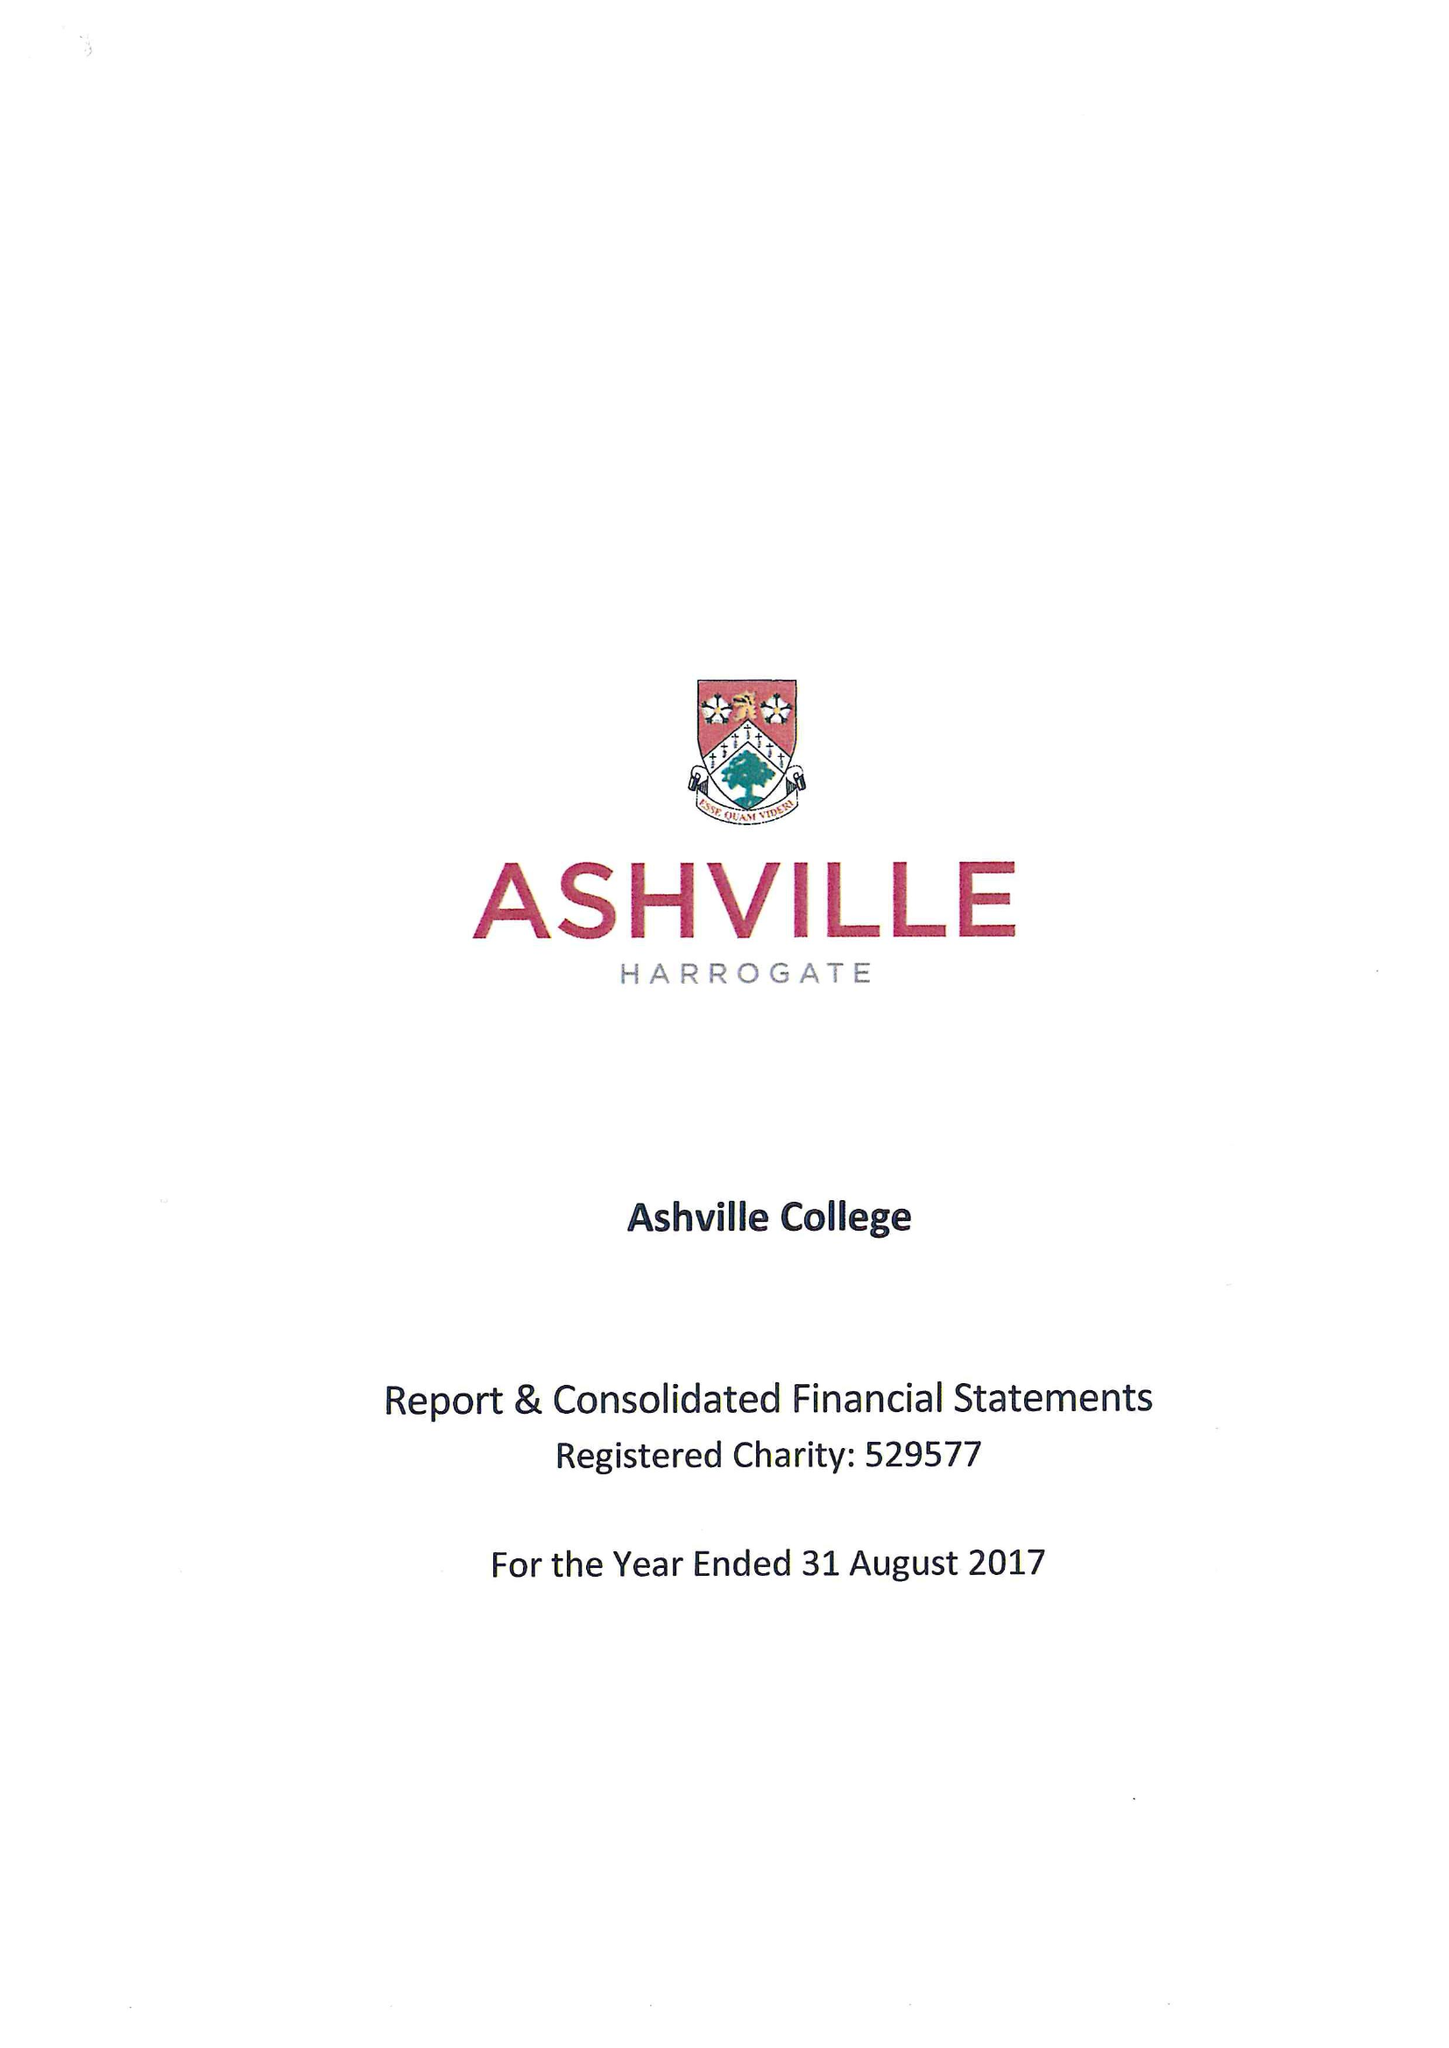What is the value for the address__postcode?
Answer the question using a single word or phrase. HG2 9JP 